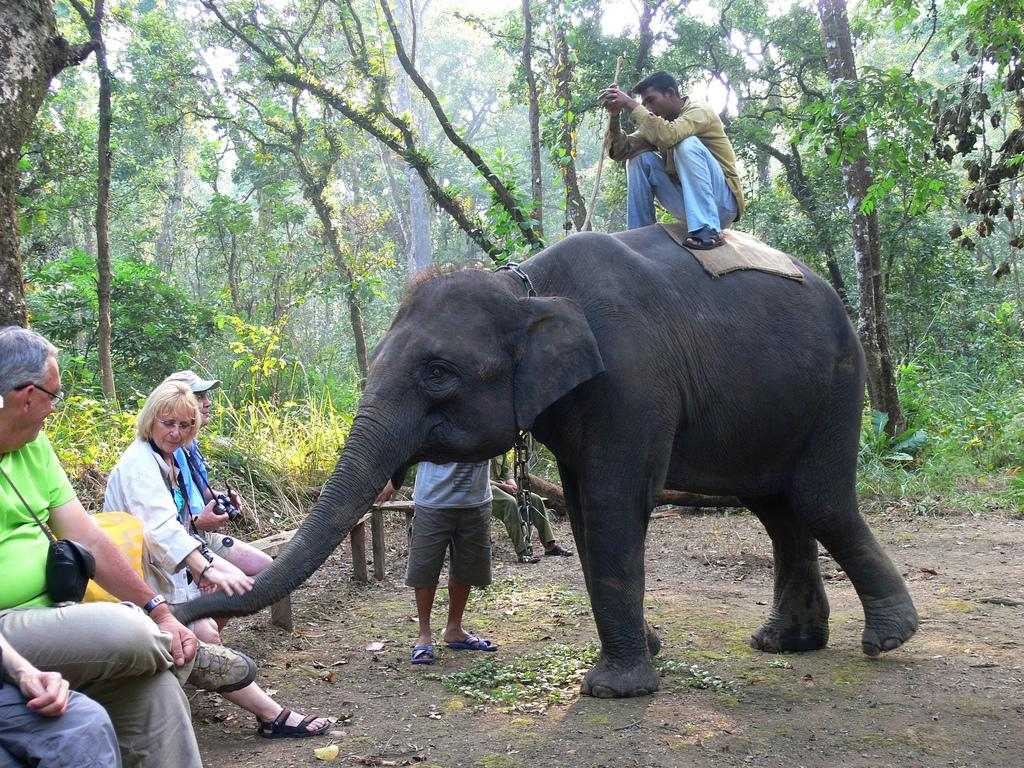Question: what type of animal is in the picture?
Choices:
A. Giraffe.
B. Lion.
C. Hippopotamus.
D. Elephant.
Answer with the letter. Answer: D Question: who has blue pants on?
Choices:
A. The man riding the bike.
B. The man going up the elevator.
C. The man on top of the elephant.
D. The man coming down the stairs.
Answer with the letter. Answer: C Question: why is the man sitting on the elephant?
Choices:
A. He is riding it.
B. He's posing for a picture.
C. He's getting married.
D. He's going on safari.
Answer with the letter. Answer: A Question: what is surrounding the people?
Choices:
A. Trees.
B. Bushes.
C. Shrubbery.
D. Weeds.
Answer with the letter. Answer: A Question: where is this picture taken?
Choices:
A. Theme park.
B. Street.
C. In a zoo.
D. City.
Answer with the letter. Answer: C Question: where is everybody?
Choices:
A. In a cleared forest area.
B. In the woods.
C. Camping.
D. Swimming.
Answer with the letter. Answer: A Question: who is the elephant reaching towards?
Choices:
A. The people sitting down.
B. The trainer.
C. The baby.
D. The little girl.
Answer with the letter. Answer: A Question: what happened to the grass in the clearing?
Choices:
A. It was dug up.
B. It has grown tall.
C. It has worn away.
D. It has been freshly mowed.
Answer with the letter. Answer: C Question: what color clothing are the tourists wearing?
Choices:
A. Bright colored clothing.
B. Dark colored clothing.
C. Red colored clothing.
D. Blue colored clothing.
Answer with the letter. Answer: A Question: how does the sky through the woods appear?
Choices:
A. Dirty.
B. Bright.
C. It is misty.
D. Cloudy.
Answer with the letter. Answer: C Question: who is holding a stick?
Choices:
A. A traveler.
B. Man walking.
C. Guy on elephant.
D. A sheep herder.
Answer with the letter. Answer: C Question: what has green leaves?
Choices:
A. Bushes.
B. The trees.
C. Herbal tea.
D. Fig trees.
Answer with the letter. Answer: B Question: who is fat?
Choices:
A. Woman in yellow.
B. Man in black pants.
C. Boy in purple shirt.
D. Man in green shirt.
Answer with the letter. Answer: D 